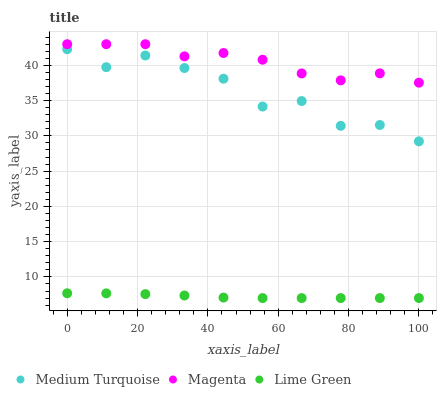Does Lime Green have the minimum area under the curve?
Answer yes or no. Yes. Does Magenta have the maximum area under the curve?
Answer yes or no. Yes. Does Medium Turquoise have the minimum area under the curve?
Answer yes or no. No. Does Medium Turquoise have the maximum area under the curve?
Answer yes or no. No. Is Lime Green the smoothest?
Answer yes or no. Yes. Is Medium Turquoise the roughest?
Answer yes or no. Yes. Is Medium Turquoise the smoothest?
Answer yes or no. No. Is Lime Green the roughest?
Answer yes or no. No. Does Lime Green have the lowest value?
Answer yes or no. Yes. Does Medium Turquoise have the lowest value?
Answer yes or no. No. Does Magenta have the highest value?
Answer yes or no. Yes. Does Medium Turquoise have the highest value?
Answer yes or no. No. Is Lime Green less than Magenta?
Answer yes or no. Yes. Is Magenta greater than Medium Turquoise?
Answer yes or no. Yes. Does Lime Green intersect Magenta?
Answer yes or no. No. 